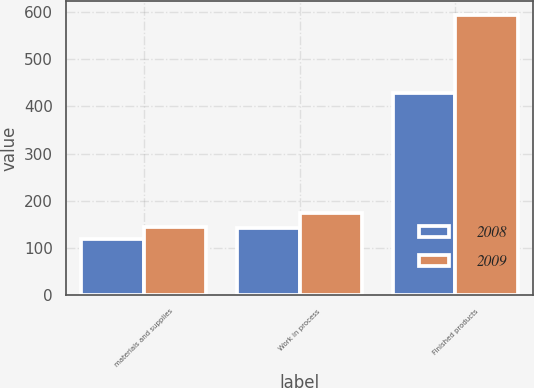<chart> <loc_0><loc_0><loc_500><loc_500><stacked_bar_chart><ecel><fcel>materials and supplies<fcel>Work in process<fcel>Finished products<nl><fcel>2008<fcel>118.5<fcel>141.6<fcel>428.1<nl><fcel>2009<fcel>143.3<fcel>174.8<fcel>594<nl></chart> 